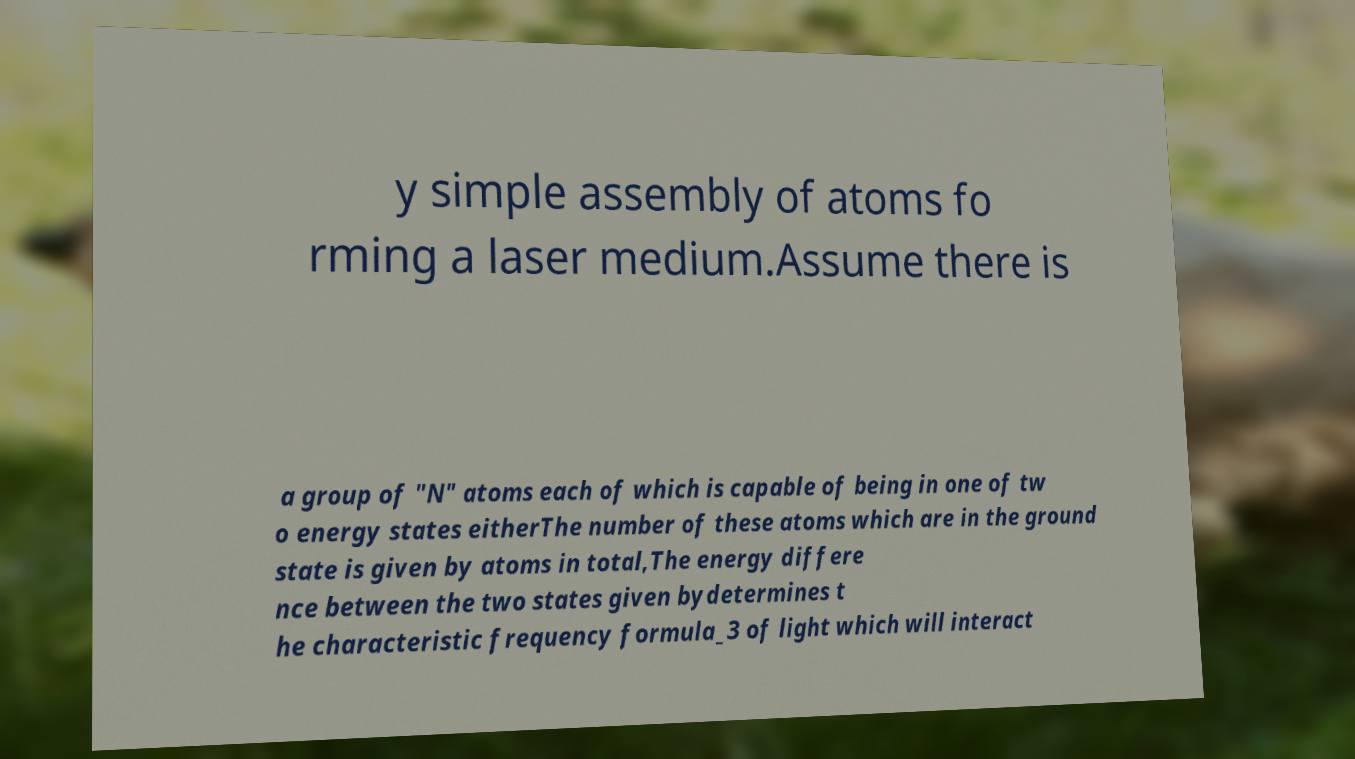Can you read and provide the text displayed in the image?This photo seems to have some interesting text. Can you extract and type it out for me? y simple assembly of atoms fo rming a laser medium.Assume there is a group of "N" atoms each of which is capable of being in one of tw o energy states eitherThe number of these atoms which are in the ground state is given by atoms in total,The energy differe nce between the two states given bydetermines t he characteristic frequency formula_3 of light which will interact 